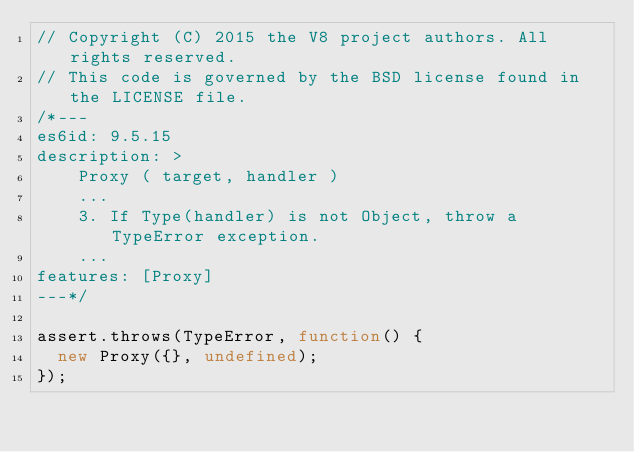<code> <loc_0><loc_0><loc_500><loc_500><_JavaScript_>// Copyright (C) 2015 the V8 project authors. All rights reserved.
// This code is governed by the BSD license found in the LICENSE file.
/*---
es6id: 9.5.15
description: >
    Proxy ( target, handler )
    ...
    3. If Type(handler) is not Object, throw a TypeError exception.
    ...
features: [Proxy]
---*/

assert.throws(TypeError, function() {
  new Proxy({}, undefined);
});
</code> 